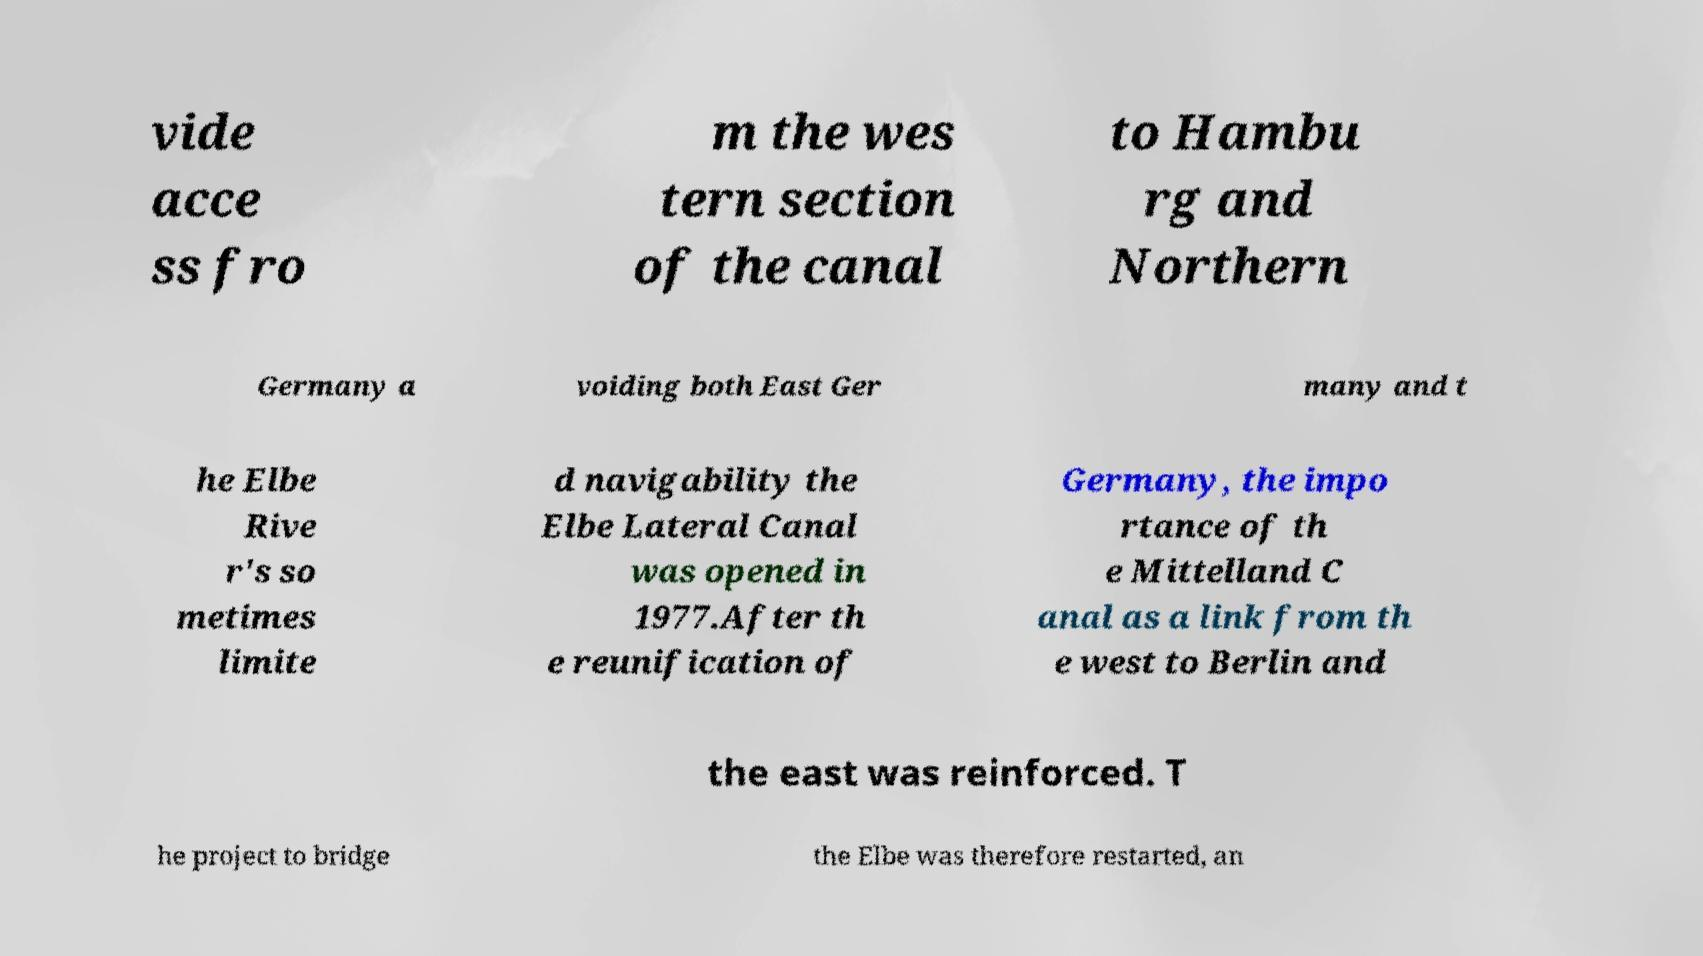Please identify and transcribe the text found in this image. vide acce ss fro m the wes tern section of the canal to Hambu rg and Northern Germany a voiding both East Ger many and t he Elbe Rive r's so metimes limite d navigability the Elbe Lateral Canal was opened in 1977.After th e reunification of Germany, the impo rtance of th e Mittelland C anal as a link from th e west to Berlin and the east was reinforced. T he project to bridge the Elbe was therefore restarted, an 